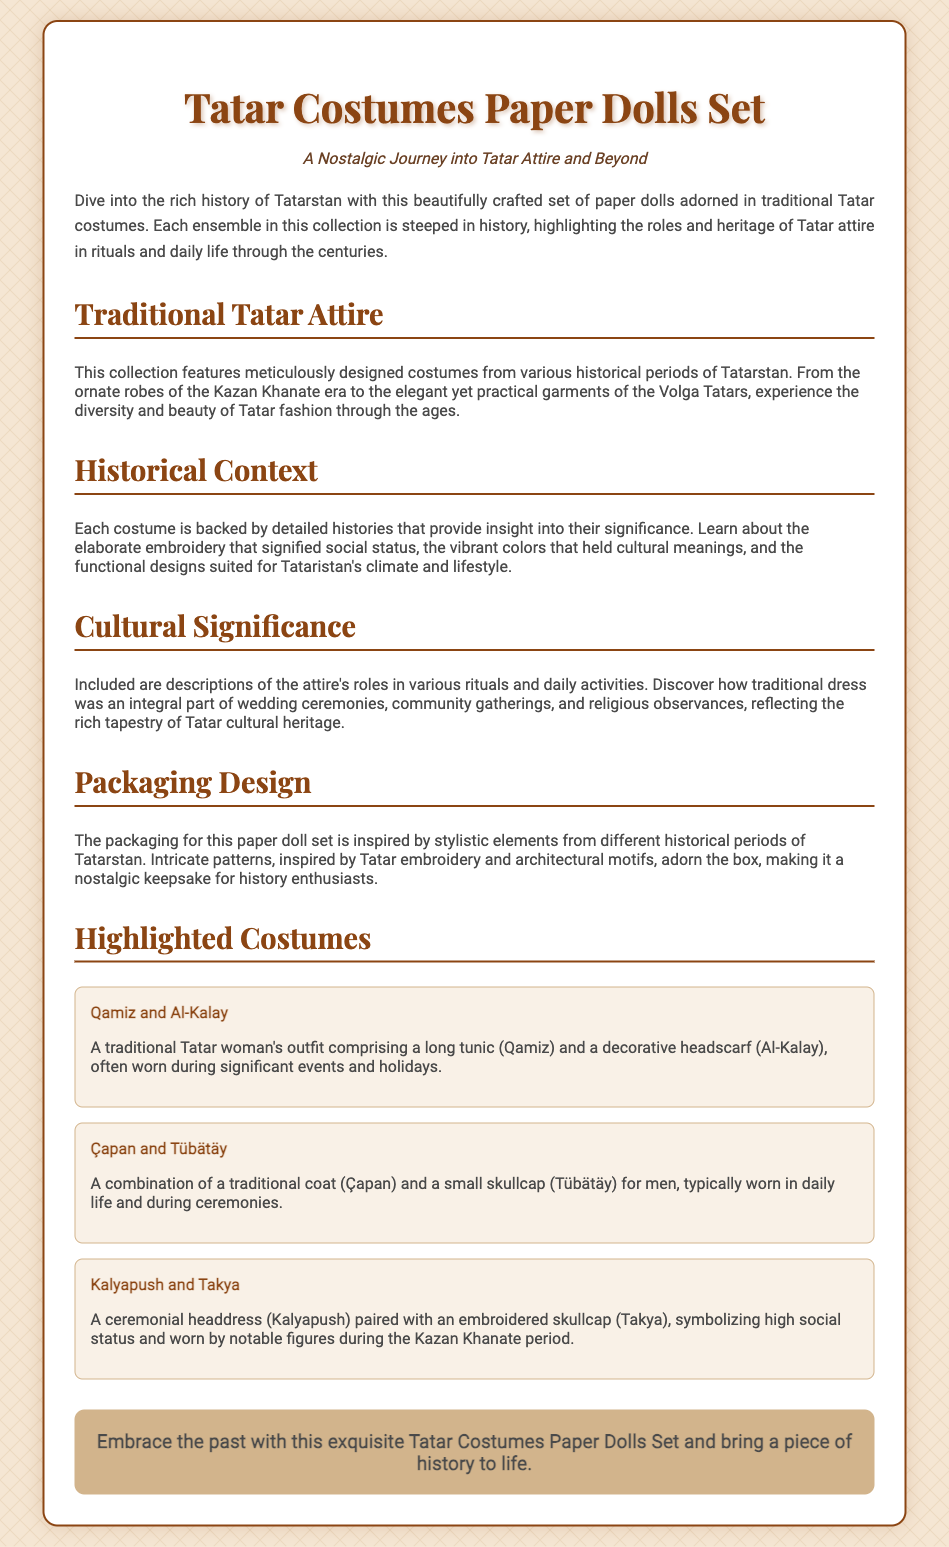What is the title of the product? The title of the product is prominently displayed at the top of the document as the main heading.
Answer: Tatar Costumes Paper Dolls Set What does the subtitle suggest? The subtitle indicates a thematic focus on nostalgia and Tatar attire from history.
Answer: A Nostalgic Journey into Tatar Attire and Beyond How many highlighted costumes are listed? The document includes a section that specifically lists the highlighted costumes, which counts how many there are.
Answer: Three What is the name of the female traditional outfit mentioned? The description of a traditional Tatar woman's outfit specifies its name in the list of highlighted costumes.
Answer: Qamiz and Al-Kalay What is the primary function of the Tatar costumes in rituals? A specific section discusses the cultural significance of the attire in various rituals and daily activities.
Answer: Integral part What period inspired the packaging design? The document mentions the inspiration for the packaging design regarding Tatarstan's history, specifying the type of periods.
Answer: Different historical periods What does the costume item “Kalyapush and Takya” symbolize? The document provides insight into how specific costumes hold meaning, particularly in relation to social status.
Answer: High social status What type of packaging design is used? The document describes the packaging's aesthetic features and their connection to Tatar cultural elements.
Answer: Intricate patterns 